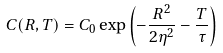Convert formula to latex. <formula><loc_0><loc_0><loc_500><loc_500>C ( R , T ) = C _ { 0 } \exp \left ( { - \frac { R ^ { 2 } } { 2 \eta ^ { 2 } } - \frac { T } { \tau } } \right )</formula> 